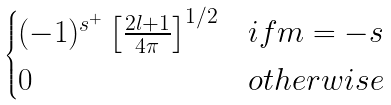Convert formula to latex. <formula><loc_0><loc_0><loc_500><loc_500>\begin{cases} ( - 1 ) ^ { s ^ { + } } \left [ \frac { 2 l + 1 } { 4 \pi } \right ] ^ { 1 / 2 } & i f m = - s \\ 0 & o t h e r w i s e \end{cases}</formula> 